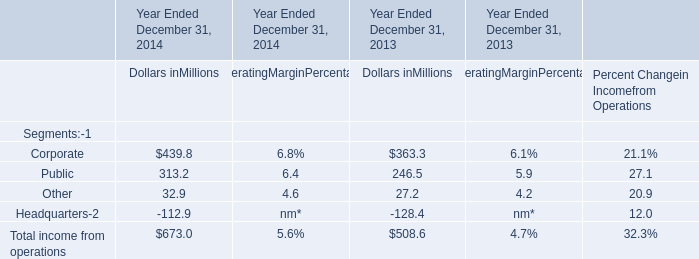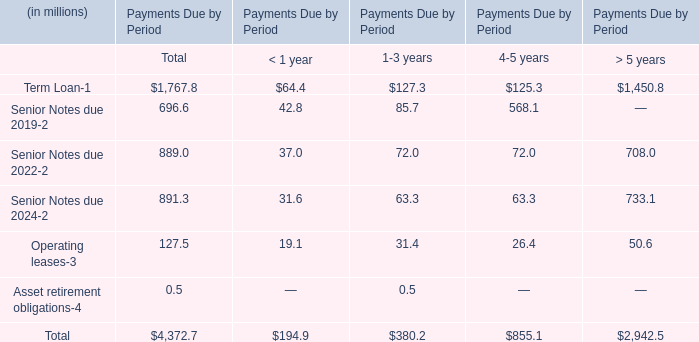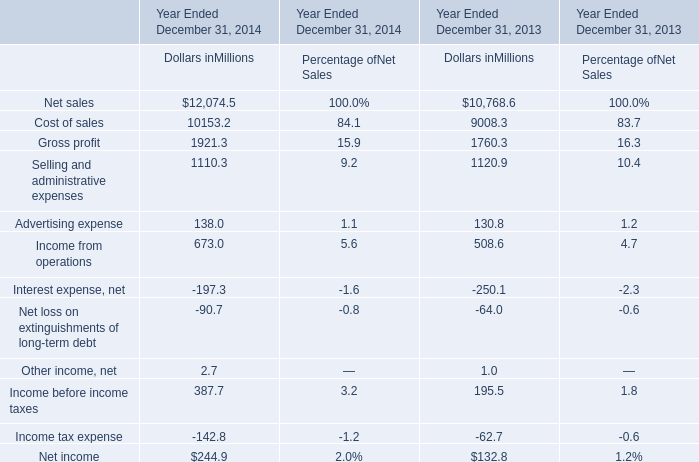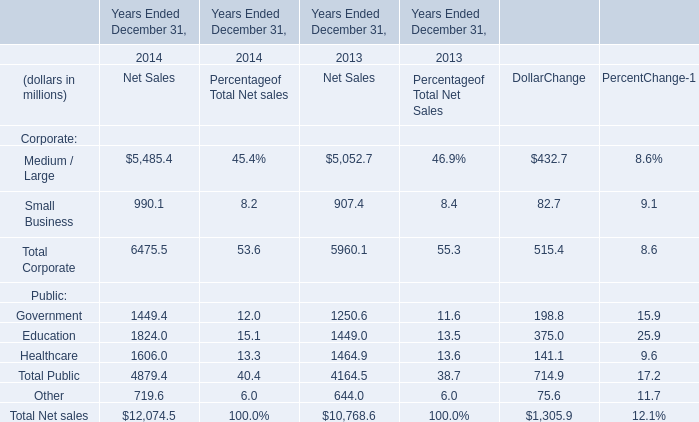What is the difference between 2014 and 2013 's highest Dollars? (in Million) 
Computations: (12074.5 - 10768.6)
Answer: 1305.9. 